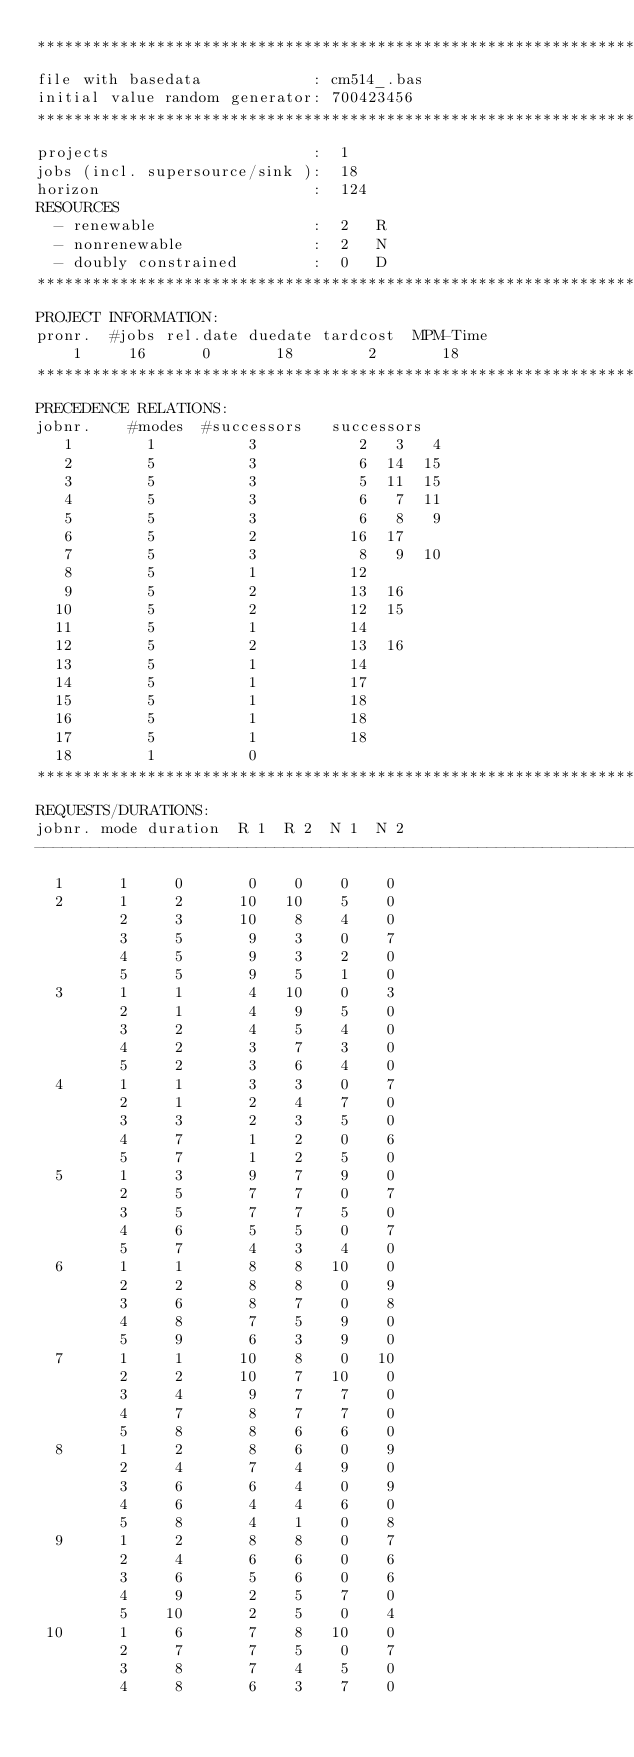Convert code to text. <code><loc_0><loc_0><loc_500><loc_500><_ObjectiveC_>************************************************************************
file with basedata            : cm514_.bas
initial value random generator: 700423456
************************************************************************
projects                      :  1
jobs (incl. supersource/sink ):  18
horizon                       :  124
RESOURCES
  - renewable                 :  2   R
  - nonrenewable              :  2   N
  - doubly constrained        :  0   D
************************************************************************
PROJECT INFORMATION:
pronr.  #jobs rel.date duedate tardcost  MPM-Time
    1     16      0       18        2       18
************************************************************************
PRECEDENCE RELATIONS:
jobnr.    #modes  #successors   successors
   1        1          3           2   3   4
   2        5          3           6  14  15
   3        5          3           5  11  15
   4        5          3           6   7  11
   5        5          3           6   8   9
   6        5          2          16  17
   7        5          3           8   9  10
   8        5          1          12
   9        5          2          13  16
  10        5          2          12  15
  11        5          1          14
  12        5          2          13  16
  13        5          1          14
  14        5          1          17
  15        5          1          18
  16        5          1          18
  17        5          1          18
  18        1          0        
************************************************************************
REQUESTS/DURATIONS:
jobnr. mode duration  R 1  R 2  N 1  N 2
------------------------------------------------------------------------
  1      1     0       0    0    0    0
  2      1     2      10   10    5    0
         2     3      10    8    4    0
         3     5       9    3    0    7
         4     5       9    3    2    0
         5     5       9    5    1    0
  3      1     1       4   10    0    3
         2     1       4    9    5    0
         3     2       4    5    4    0
         4     2       3    7    3    0
         5     2       3    6    4    0
  4      1     1       3    3    0    7
         2     1       2    4    7    0
         3     3       2    3    5    0
         4     7       1    2    0    6
         5     7       1    2    5    0
  5      1     3       9    7    9    0
         2     5       7    7    0    7
         3     5       7    7    5    0
         4     6       5    5    0    7
         5     7       4    3    4    0
  6      1     1       8    8   10    0
         2     2       8    8    0    9
         3     6       8    7    0    8
         4     8       7    5    9    0
         5     9       6    3    9    0
  7      1     1      10    8    0   10
         2     2      10    7   10    0
         3     4       9    7    7    0
         4     7       8    7    7    0
         5     8       8    6    6    0
  8      1     2       8    6    0    9
         2     4       7    4    9    0
         3     6       6    4    0    9
         4     6       4    4    6    0
         5     8       4    1    0    8
  9      1     2       8    8    0    7
         2     4       6    6    0    6
         3     6       5    6    0    6
         4     9       2    5    7    0
         5    10       2    5    0    4
 10      1     6       7    8   10    0
         2     7       7    5    0    7
         3     8       7    4    5    0
         4     8       6    3    7    0</code> 